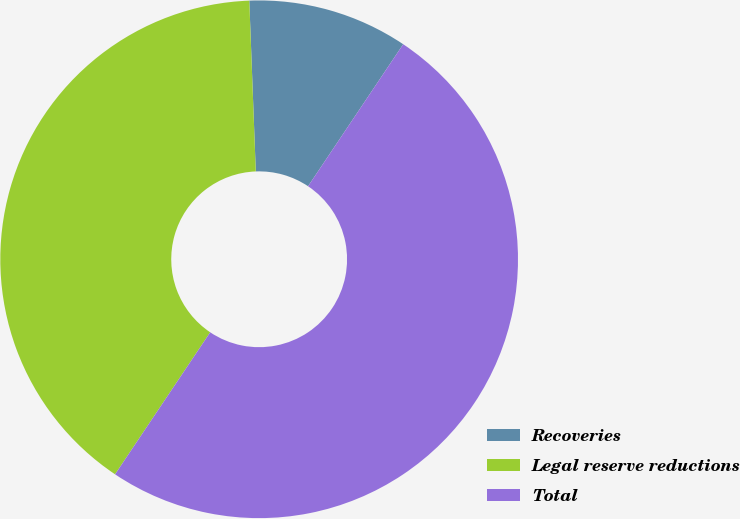<chart> <loc_0><loc_0><loc_500><loc_500><pie_chart><fcel>Recoveries<fcel>Legal reserve reductions<fcel>Total<nl><fcel>10.0%<fcel>40.0%<fcel>50.0%<nl></chart> 